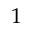Convert formula to latex. <formula><loc_0><loc_0><loc_500><loc_500>1</formula> 